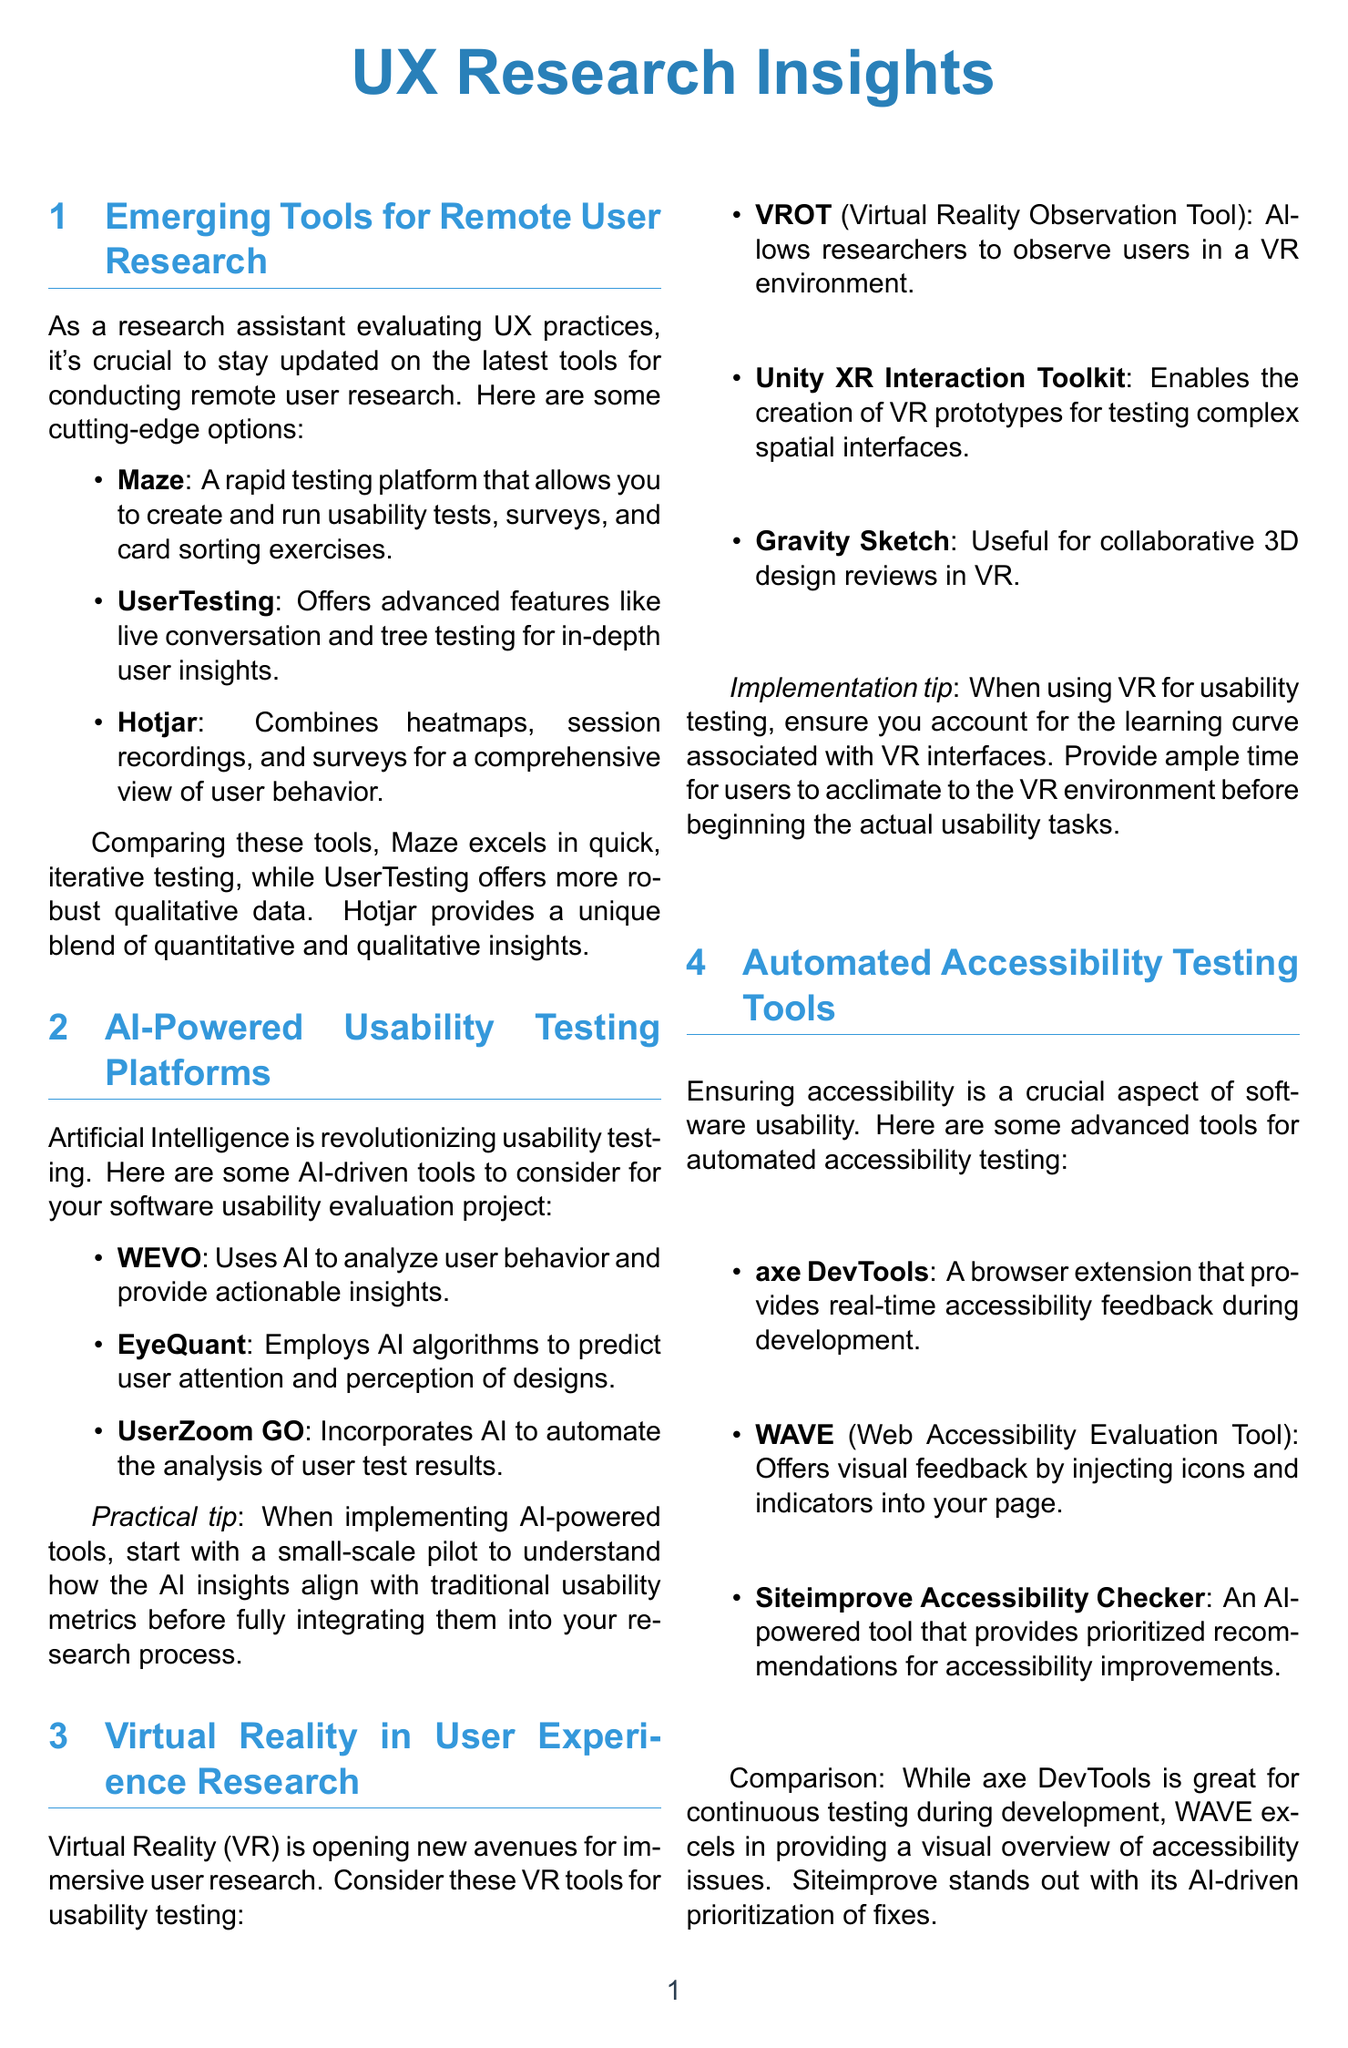what tool allows you to create and run usability tests, surveys, and card sorting exercises? The document states that Maze is a rapid testing platform that allows for these activities.
Answer: Maze which AI tool uses algorithms to predict user attention? EyeQuant is mentioned in the document as using AI algorithms for this purpose.
Answer: EyeQuant what is a practical tip when implementing AI-powered usability testing tools? The tip suggests starting with a small-scale pilot before full integration into the research process.
Answer: small-scale pilot what unique feature does Hotjar offer? The document describes Hotjar as combining heatmaps, session recordings, and surveys for user behavior insights.
Answer: heatmaps, session recordings, and surveys which tool is specifically designed for observing users in a VR environment? The document lists VROT as the tool for this purpose.
Answer: VROT what does the axe DevTools tool provide during development? axe DevTools is explained as providing real-time accessibility feedback.
Answer: real-time accessibility feedback which tool analyzes facial expressions to gauge user emotions? Affectiva is mentioned as a tool that uses facial expression analysis for this purpose.
Answer: Affectiva how many tools are listed under AI-Powered Usability Testing Platforms? There are three AI tools mentioned in this section.
Answer: three what is the focus of the section on Automated Accessibility Testing Tools? This section's focus is on ensuring accessibility in software usability through certain tools.
Answer: accessibility what implementation tip is suggested for using VR in usability testing? The tip indicates the need to account for the learning curve associated with VR interfaces.
Answer: learning curve 